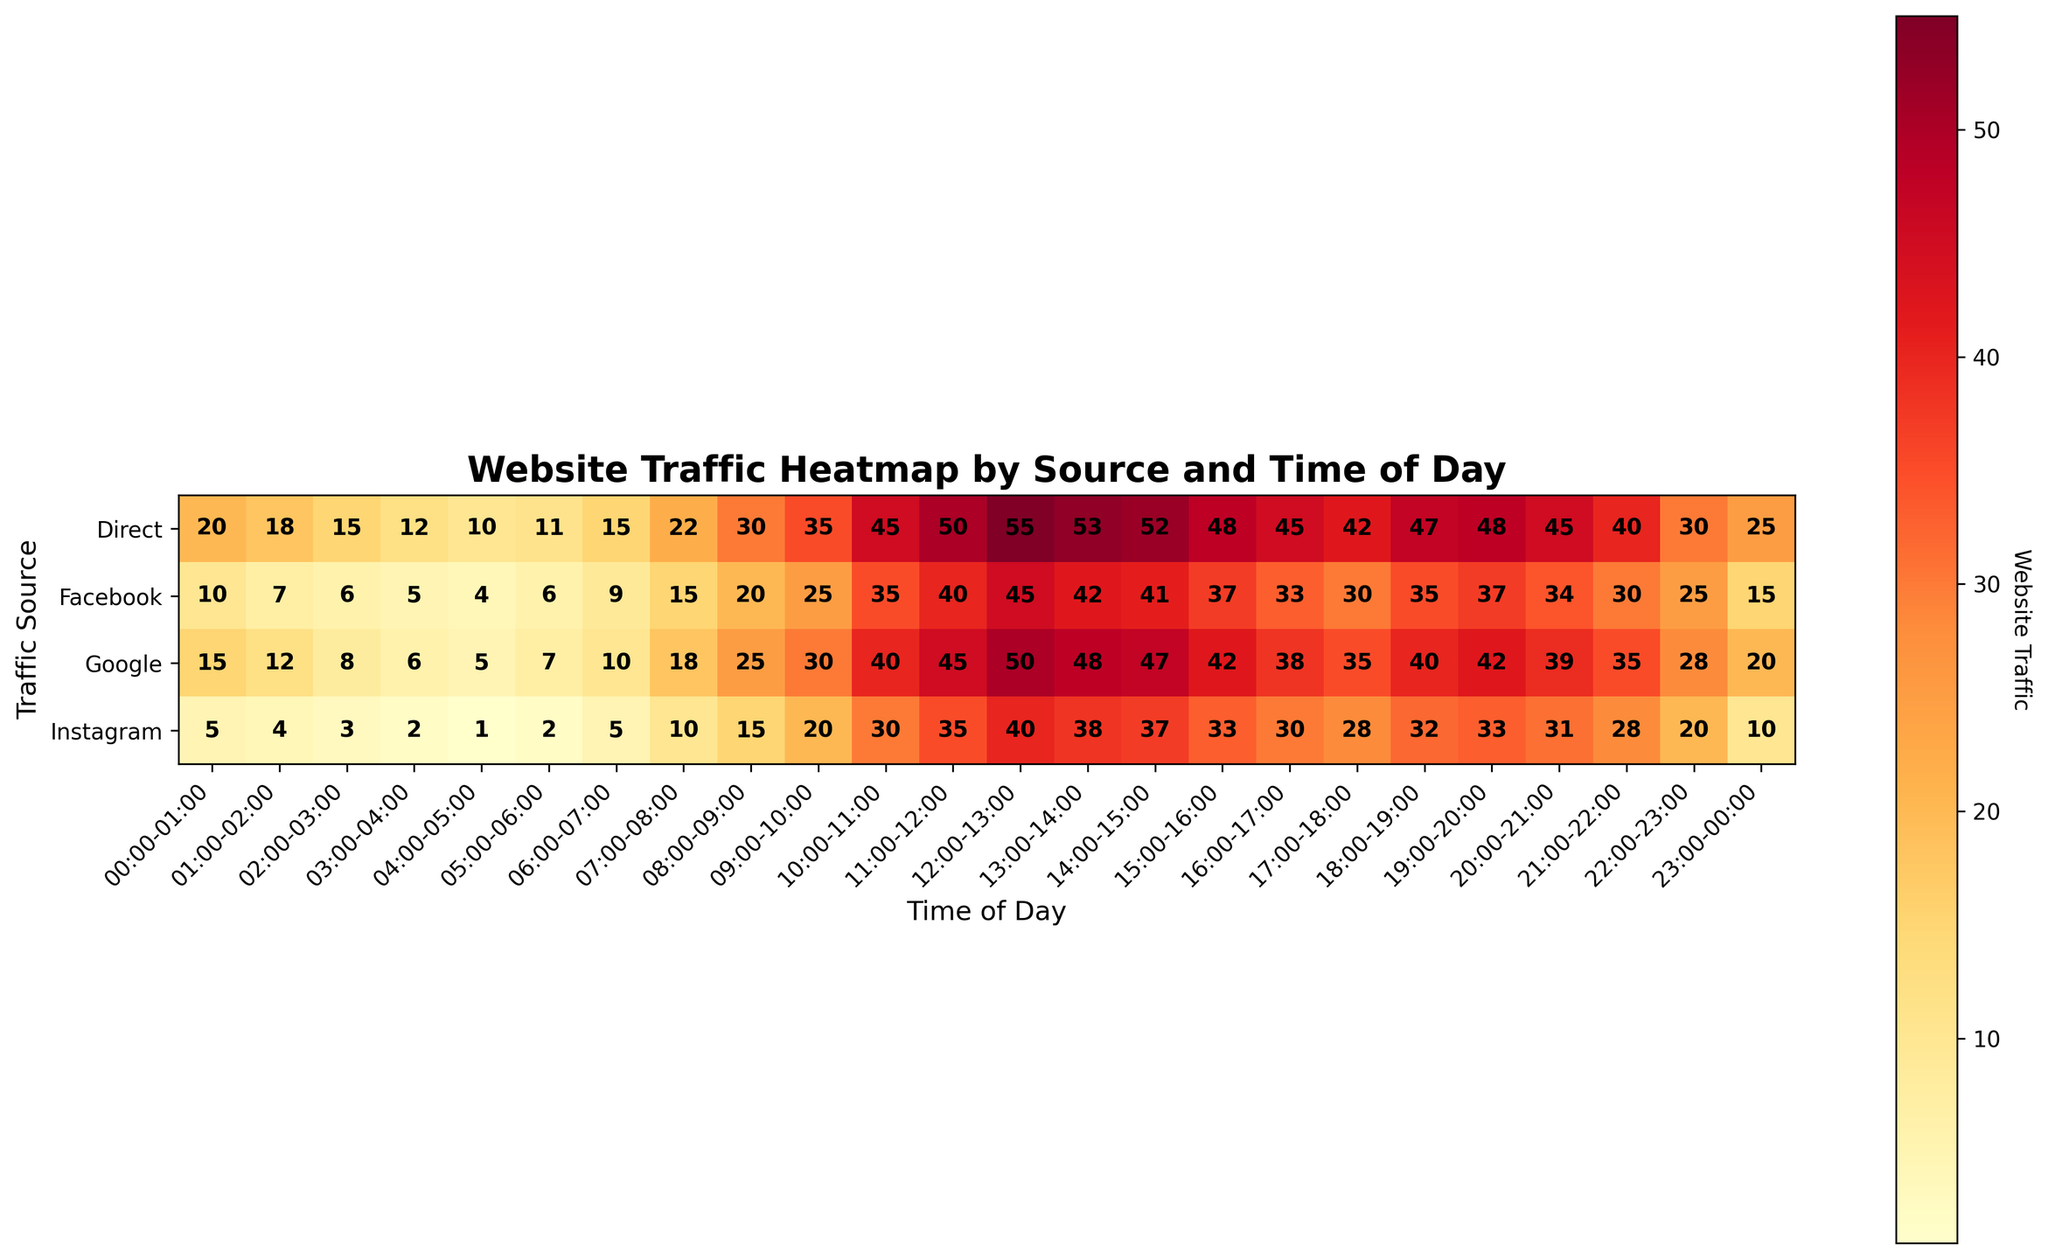What is the title of the heatmap? The title is usually placed at the top of the heatmap and often gives an overview of what is being depicted. In this case, it should describe the main focus of the data visualized.
Answer: Website Traffic Heatmap by Source and Time of Day Which time of day has the highest website traffic from Google? To determine the highest traffic period from Google, look for the cell with the largest number in the row labeled "Google".
Answer: 12:00-13:00 How does the traffic from Facebook at 10:00-11:00 compare to the traffic from Instagram at the same time? Find the values in the cells where the "Facebook" row and the "Instagram" row intersect with the "10:00-11:00" column, and compare these values.
Answer: Facebook has 35, Instagram has 30, so Facebook has higher traffic What time of day does Direct traffic peak? Identify the cell with the maximum value in the row labeled "Direct" to find when traffic is highest.
Answer: 12:00-13:00 What is the average traffic for Google between 09:00 and 13:00 (inclusive)? Sum the values in the "Google" row from the columns "09:00-10:00" to "12:00-13:00" (30 + 40 + 45 + 50), then divide by the number of time periods (4).
Answer: (30 + 40 + 45 + 50)/4 = 41.25 Which source has the least traffic at 03:00-04:00? Compare the values in the column titled "03:00-04:00" across all sources to find the smallest value.
Answer: Instagram Is the traffic from Direct higher than Facebook at 19:00-20:00? Check the values at the 19:00-20:00 column for both Direct and Facebook rows and see if the value for Direct is greater than for Facebook.
Answer: Yes (Direct=48, Facebook=37) What is the median traffic for Instagram in a day? List out all 24 traffic values for Instagram from each hour, sort them, and find the middle value (or the average of the two middle values if there is an even number of values).
Answer: Median value after sorting 24 hourly traffic values is 20.5 